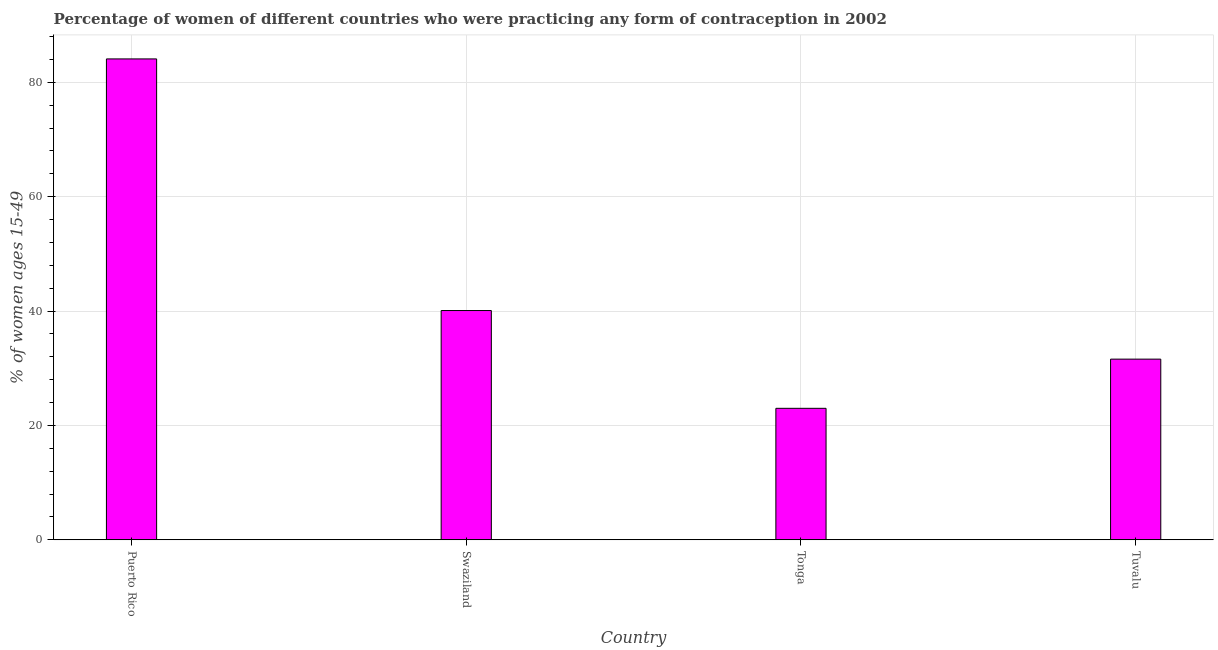What is the title of the graph?
Keep it short and to the point. Percentage of women of different countries who were practicing any form of contraception in 2002. What is the label or title of the Y-axis?
Provide a succinct answer. % of women ages 15-49. What is the contraceptive prevalence in Swaziland?
Make the answer very short. 40.1. Across all countries, what is the maximum contraceptive prevalence?
Give a very brief answer. 84.1. Across all countries, what is the minimum contraceptive prevalence?
Offer a terse response. 23. In which country was the contraceptive prevalence maximum?
Provide a short and direct response. Puerto Rico. In which country was the contraceptive prevalence minimum?
Keep it short and to the point. Tonga. What is the sum of the contraceptive prevalence?
Your response must be concise. 178.8. What is the difference between the contraceptive prevalence in Puerto Rico and Tonga?
Give a very brief answer. 61.1. What is the average contraceptive prevalence per country?
Give a very brief answer. 44.7. What is the median contraceptive prevalence?
Your answer should be compact. 35.85. What is the ratio of the contraceptive prevalence in Swaziland to that in Tuvalu?
Provide a succinct answer. 1.27. What is the difference between the highest and the lowest contraceptive prevalence?
Offer a terse response. 61.1. In how many countries, is the contraceptive prevalence greater than the average contraceptive prevalence taken over all countries?
Your response must be concise. 1. How many bars are there?
Give a very brief answer. 4. Are all the bars in the graph horizontal?
Your answer should be compact. No. What is the % of women ages 15-49 of Puerto Rico?
Provide a succinct answer. 84.1. What is the % of women ages 15-49 of Swaziland?
Ensure brevity in your answer.  40.1. What is the % of women ages 15-49 of Tonga?
Give a very brief answer. 23. What is the % of women ages 15-49 of Tuvalu?
Your response must be concise. 31.6. What is the difference between the % of women ages 15-49 in Puerto Rico and Swaziland?
Give a very brief answer. 44. What is the difference between the % of women ages 15-49 in Puerto Rico and Tonga?
Your answer should be very brief. 61.1. What is the difference between the % of women ages 15-49 in Puerto Rico and Tuvalu?
Keep it short and to the point. 52.5. What is the difference between the % of women ages 15-49 in Swaziland and Tonga?
Ensure brevity in your answer.  17.1. What is the difference between the % of women ages 15-49 in Swaziland and Tuvalu?
Provide a short and direct response. 8.5. What is the ratio of the % of women ages 15-49 in Puerto Rico to that in Swaziland?
Ensure brevity in your answer.  2.1. What is the ratio of the % of women ages 15-49 in Puerto Rico to that in Tonga?
Your answer should be compact. 3.66. What is the ratio of the % of women ages 15-49 in Puerto Rico to that in Tuvalu?
Ensure brevity in your answer.  2.66. What is the ratio of the % of women ages 15-49 in Swaziland to that in Tonga?
Your answer should be compact. 1.74. What is the ratio of the % of women ages 15-49 in Swaziland to that in Tuvalu?
Your response must be concise. 1.27. What is the ratio of the % of women ages 15-49 in Tonga to that in Tuvalu?
Provide a short and direct response. 0.73. 